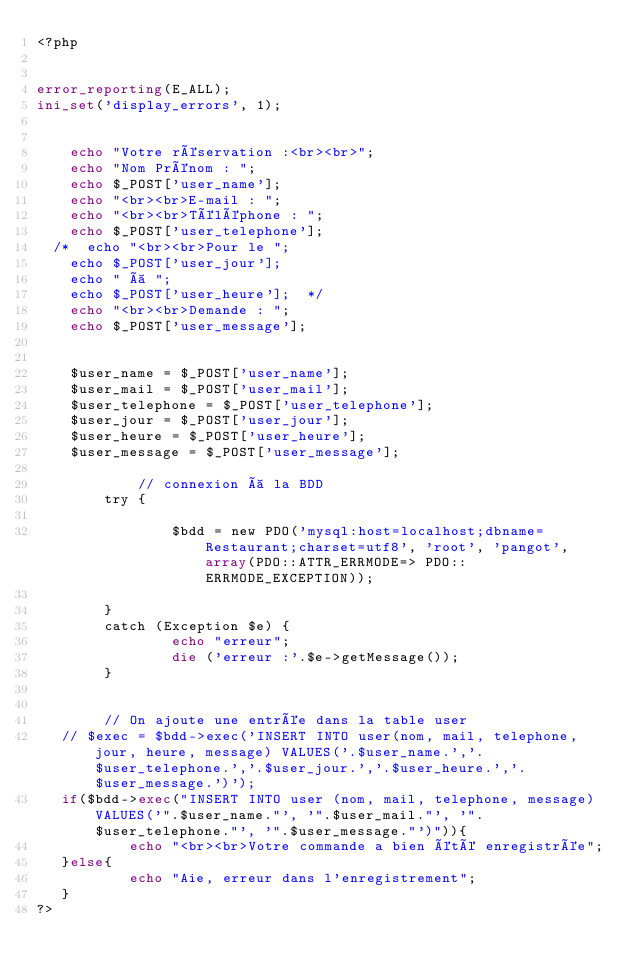Convert code to text. <code><loc_0><loc_0><loc_500><loc_500><_PHP_><?php


error_reporting(E_ALL);
ini_set('display_errors', 1);


    echo "Votre réservation :<br><br>";
    echo "Nom Prénom : ";
    echo $_POST['user_name'];
    echo "<br><br>E-mail : ";
    echo "<br><br>Téléphone : ";
    echo $_POST['user_telephone'];
  /*  echo "<br><br>Pour le ";
    echo $_POST['user_jour'];
    echo " à ";
    echo $_POST['user_heure'];  */
    echo "<br><br>Demande : ";
    echo $_POST['user_message'];  

        
    $user_name = $_POST['user_name'];
    $user_mail = $_POST['user_mail'];
    $user_telephone = $_POST['user_telephone'];
    $user_jour = $_POST['user_jour'];
    $user_heure = $_POST['user_heure'];
    $user_message = $_POST['user_message']; 
    
            // connexion à la BDD
        try {
                
                $bdd = new PDO('mysql:host=localhost;dbname=Restaurant;charset=utf8', 'root', 'pangot', array(PDO::ATTR_ERRMODE=> PDO::ERRMODE_EXCEPTION));
                
        }
        catch (Exception $e) {
                echo "erreur";
                die ('erreur :'.$e->getMessage());           
        }

        
        // On ajoute une entrée dans la table user
   // $exec = $bdd->exec('INSERT INTO user(nom, mail, telephone, jour, heure, message) VALUES('.$user_name.','.$user_telephone.','.$user_jour.','.$user_heure.','.$user_message.')');
   if($bdd->exec("INSERT INTO user (nom, mail, telephone, message) VALUES('".$user_name."', '".$user_mail."', '".$user_telephone."', '".$user_message."')")){
           echo "<br><br>Votre commande a bien été enregistrée";
   }else{
           echo "Aie, erreur dans l'enregistrement";
   }
?>


</code> 